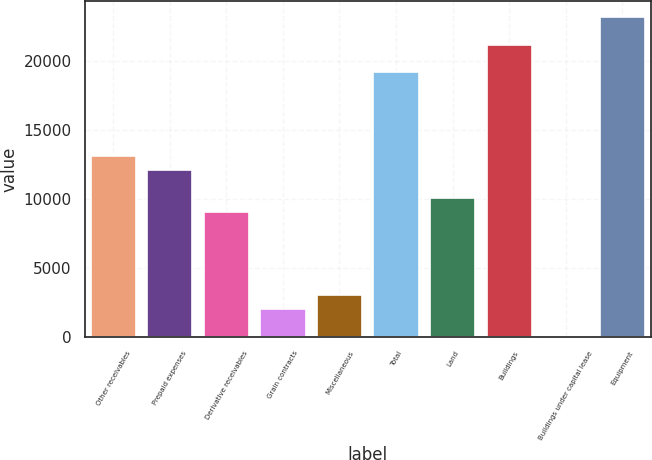<chart> <loc_0><loc_0><loc_500><loc_500><bar_chart><fcel>Other receivables<fcel>Prepaid expenses<fcel>Derivative receivables<fcel>Grain contracts<fcel>Miscellaneous<fcel>Total<fcel>Land<fcel>Buildings<fcel>Buildings under capital lease<fcel>Equipment<nl><fcel>13104.6<fcel>12096.5<fcel>9072.48<fcel>2016.34<fcel>3024.36<fcel>19152.7<fcel>10080.5<fcel>21168.7<fcel>0.3<fcel>23184.8<nl></chart> 